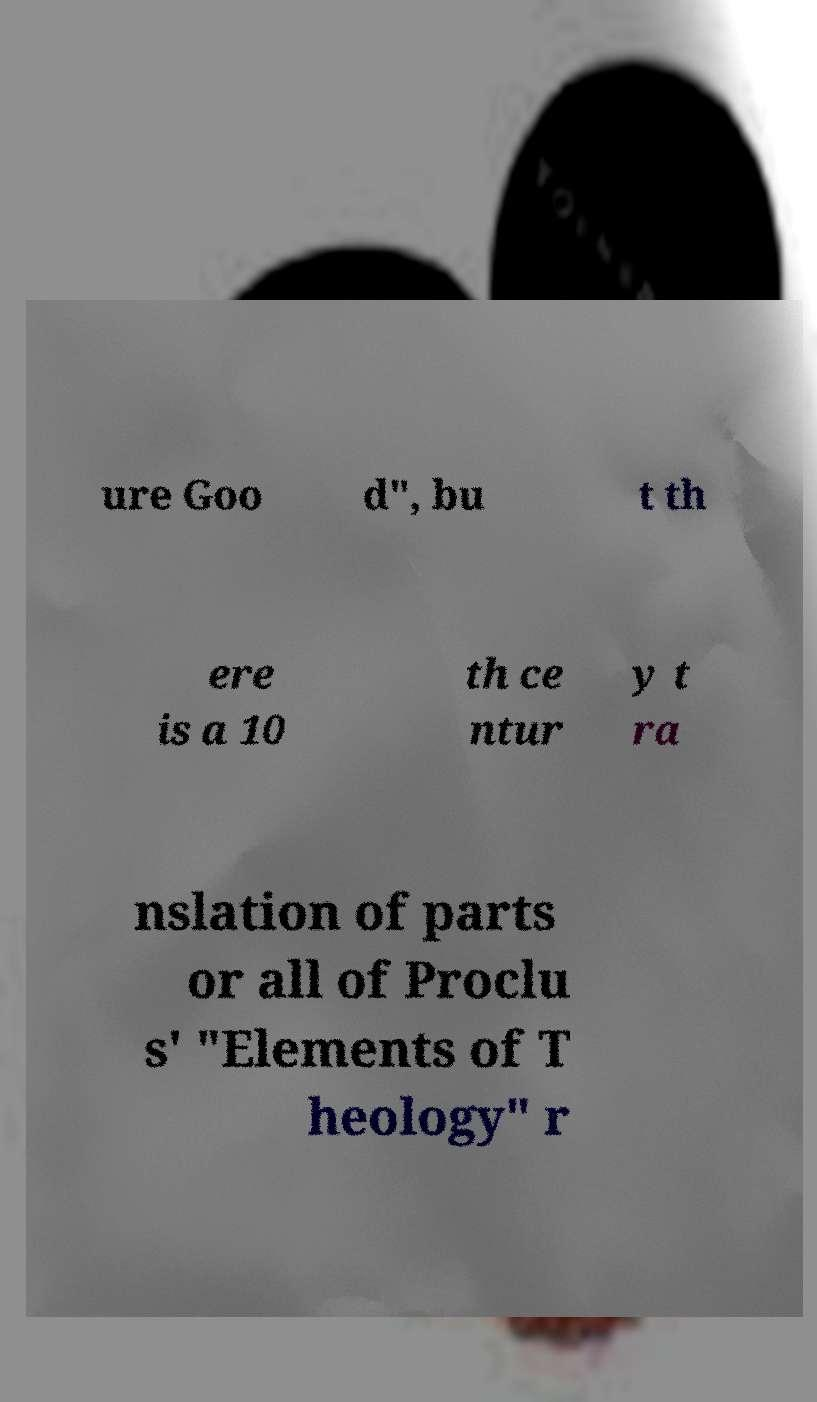Can you accurately transcribe the text from the provided image for me? ure Goo d", bu t th ere is a 10 th ce ntur y t ra nslation of parts or all of Proclu s' "Elements of T heology" r 